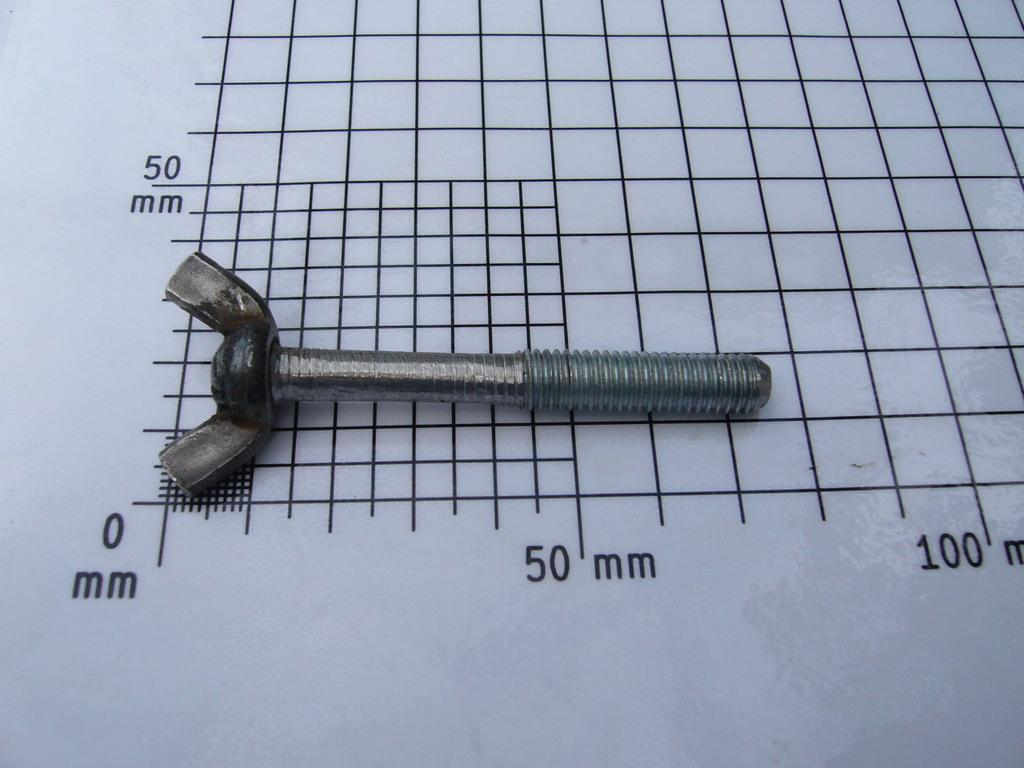Provide a one-sentence caption for the provided image. A wing nut lies on top of a measuring grid that has marks for 0, 50, and 100 millimeters. 